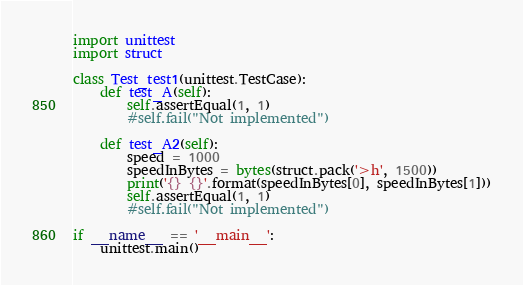Convert code to text. <code><loc_0><loc_0><loc_500><loc_500><_Python_>import unittest
import struct

class Test_test1(unittest.TestCase):
    def test_A(self):
        self.assertEqual(1, 1)
        #self.fail("Not implemented")

    def test_A2(self): 
        speed = 1000
        speedInBytes = bytes(struct.pack('>h', 1500))
        print('{} {}'.format(speedInBytes[0], speedInBytes[1]))
        self.assertEqual(1, 1)
        #self.fail("Not implemented")  

if __name__ == '__main__':
    unittest.main()
</code> 